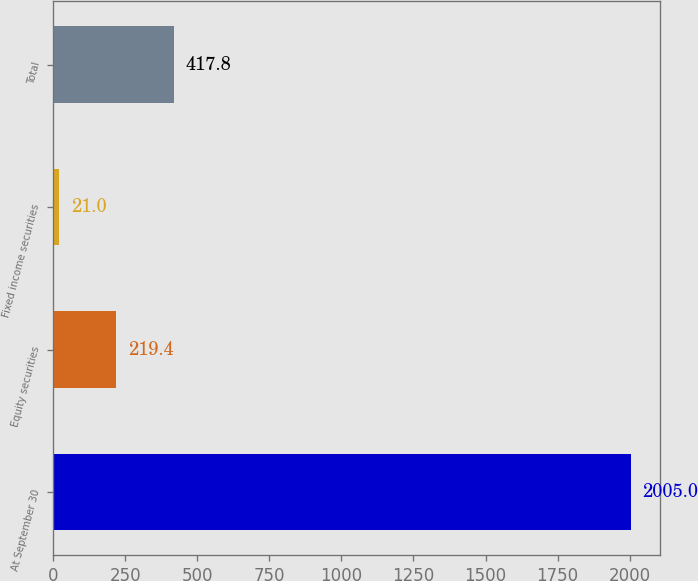Convert chart. <chart><loc_0><loc_0><loc_500><loc_500><bar_chart><fcel>At September 30<fcel>Equity securities<fcel>Fixed income securities<fcel>Total<nl><fcel>2005<fcel>219.4<fcel>21<fcel>417.8<nl></chart> 